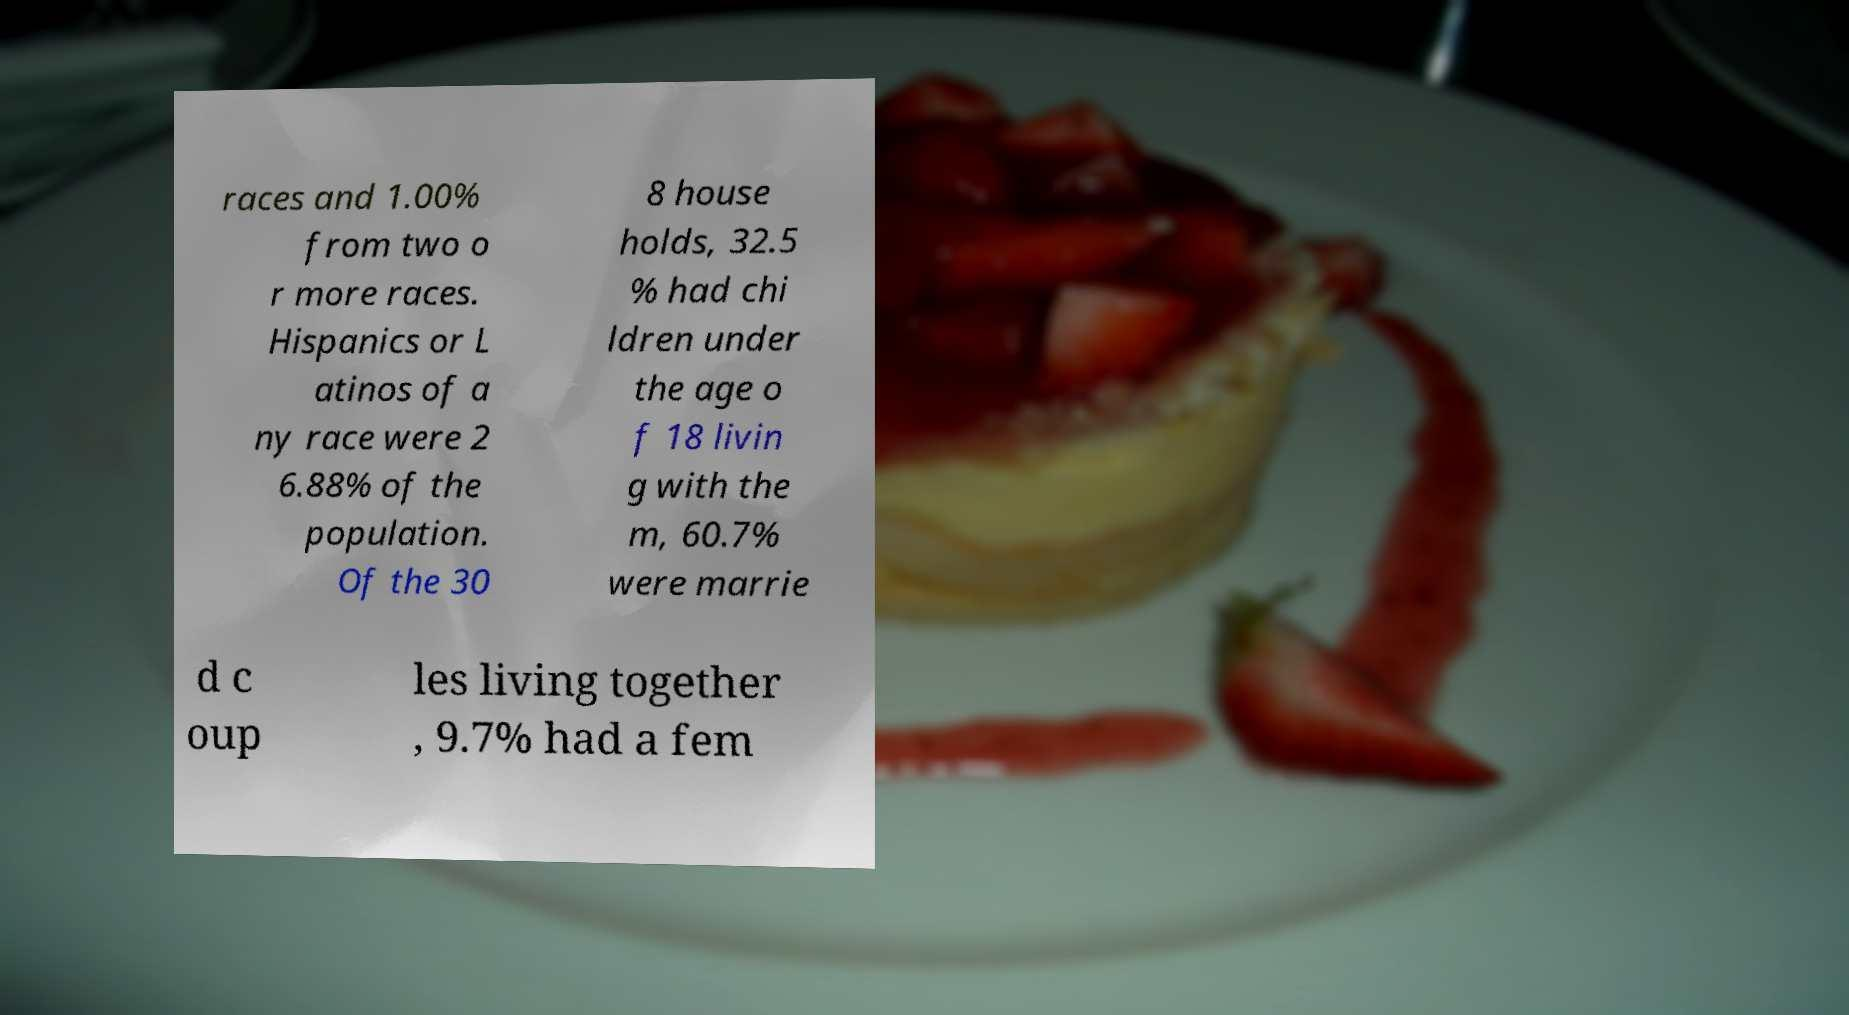For documentation purposes, I need the text within this image transcribed. Could you provide that? races and 1.00% from two o r more races. Hispanics or L atinos of a ny race were 2 6.88% of the population. Of the 30 8 house holds, 32.5 % had chi ldren under the age o f 18 livin g with the m, 60.7% were marrie d c oup les living together , 9.7% had a fem 